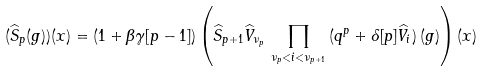<formula> <loc_0><loc_0><loc_500><loc_500>( \widehat { S } _ { p } ( g ) ) ( x ) = ( 1 + \beta \gamma [ p - 1 ] ) \left ( \widehat { S } _ { p + 1 } \widehat { V } _ { \nu _ { p } } \, \prod _ { \nu _ { p } < i < \nu _ { p + 1 } } \, ( q ^ { p } + \delta [ p ] \widehat { V } _ { i } ) \, ( g ) \right ) ( x )</formula> 